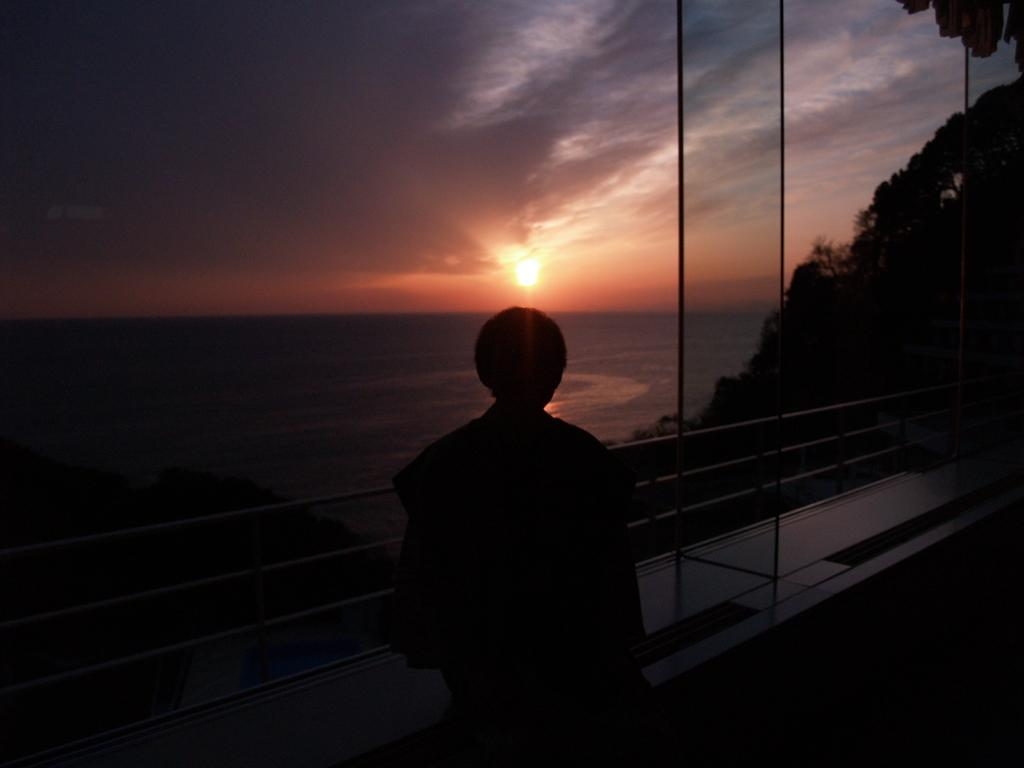What is the main subject in the image? There is a person standing in the image. What type of natural environment is visible in the image? There are trees and water visible in the image. What architectural feature can be seen in the image? There is a fence in the image. What celestial body is visible in the background of the image? The sun is visible in the background of the image. What else can be seen in the background of the image? The sky with clouds is visible in the background of the image. How many matches are being used by the person in the image? There is no indication of matches or any match-related activity in the image. 